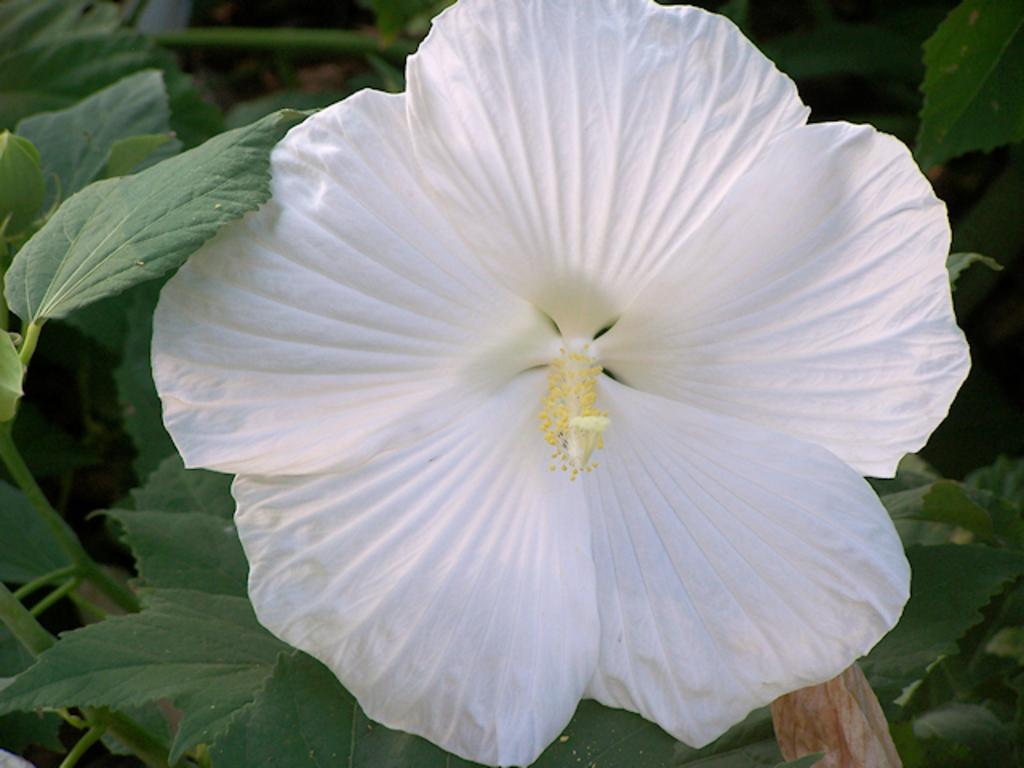What type of plant is visible in the image? There is a flower in the image. What else can be seen in the image besides the flower? There are leaves in the image. How many cars are parked near the flower in the image? There are no cars present in the image; it only features a flower and leaves. What type of glass object is visible in the image? There is no glass object present in the image. 